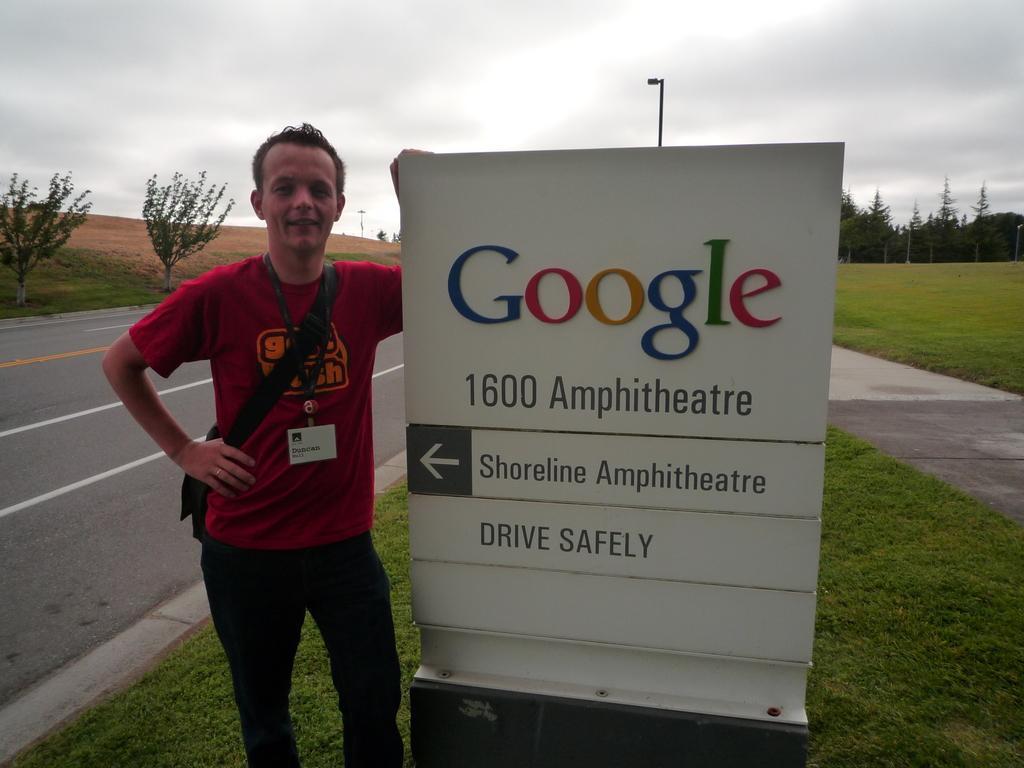What organization is this man at?
Provide a short and direct response. Google. How does the sign tell you to drive?
Keep it short and to the point. Safely. 